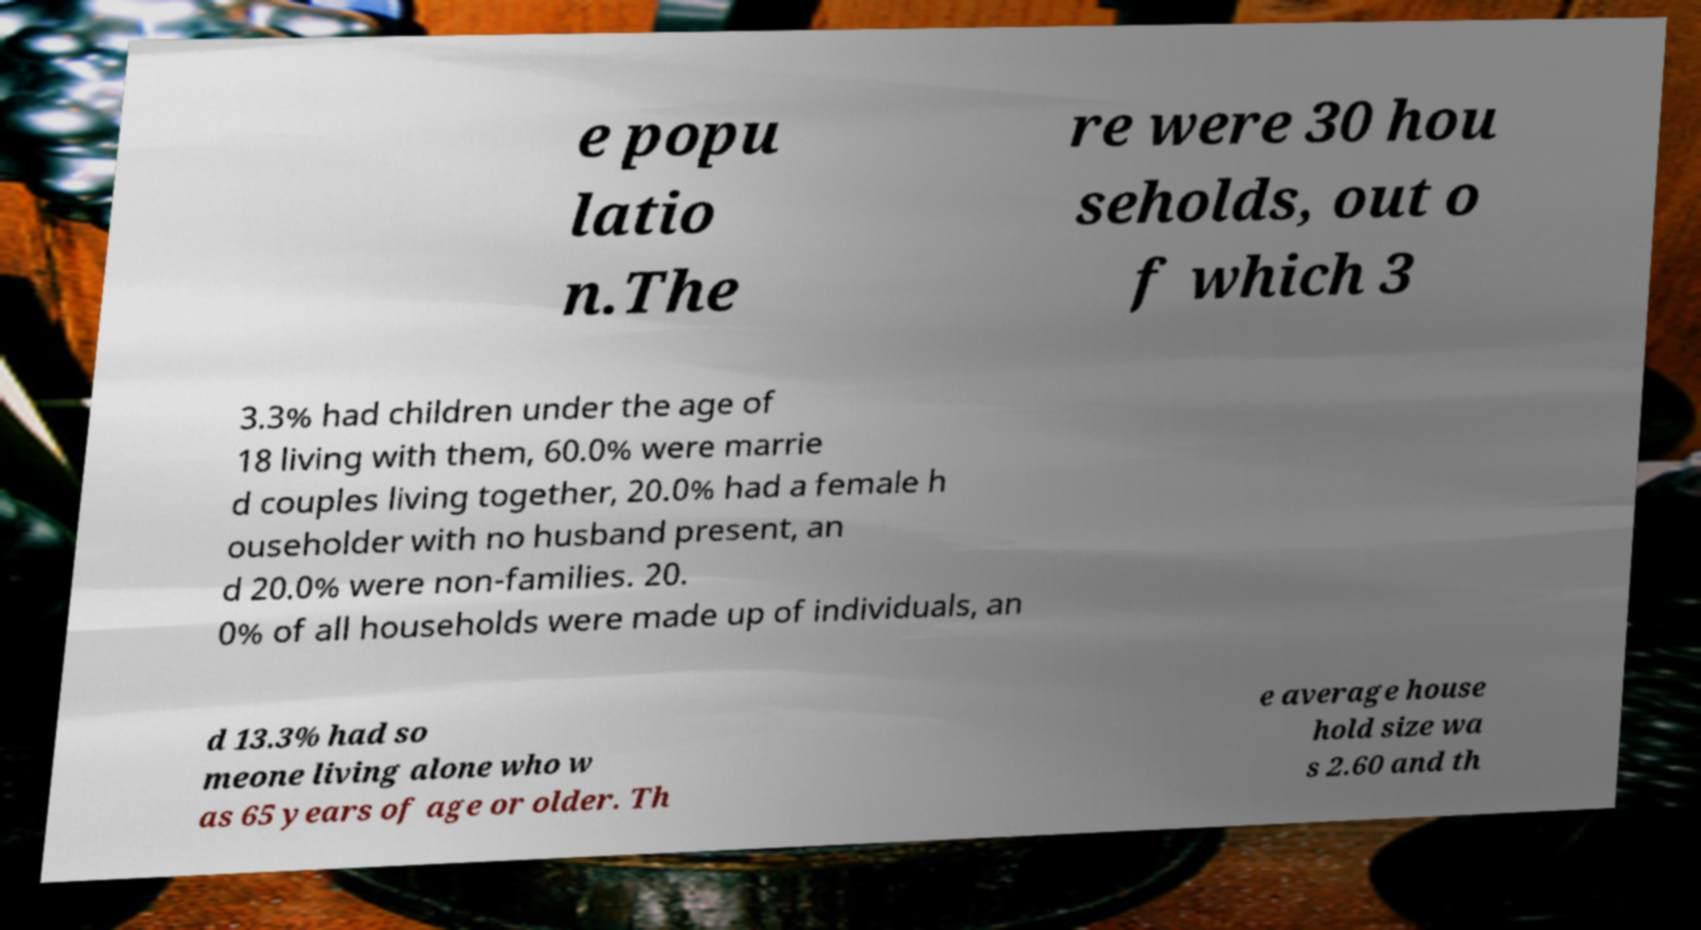Can you accurately transcribe the text from the provided image for me? e popu latio n.The re were 30 hou seholds, out o f which 3 3.3% had children under the age of 18 living with them, 60.0% were marrie d couples living together, 20.0% had a female h ouseholder with no husband present, an d 20.0% were non-families. 20. 0% of all households were made up of individuals, an d 13.3% had so meone living alone who w as 65 years of age or older. Th e average house hold size wa s 2.60 and th 